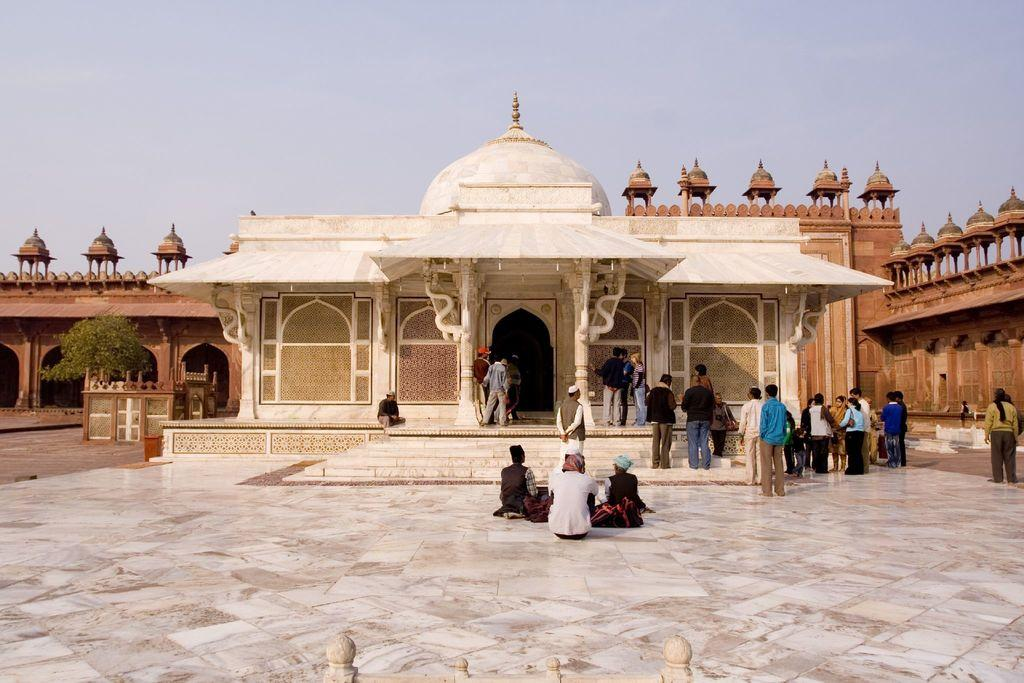What type of architecture is depicted in the image? There is a building with pillars and arches in the image. What is happening in front of the building? There are many people in front of the building. What can be seen on the left side of the image? There is a tree on the left side of the image. What is visible in the background of the image? The sky is visible in the background of the image. What hobbies do the people in the image have? There is no information about the hobbies of the people in the image. --- Facts: 1. There is a car in the image. 2. The car is red. 3. The car has four wheels. 4. There is a road in the image. 5. The road is paved. Absurd Topics: parrot, ocean, dance Conversation: What is the main subject of the image? The main subject of the image is a car. What color is the car? The car is red. How many wheels does the car have? The car has four wheels. What is the surface of the road in the image? The road is paved. Reasoning: Let's think step by step in order to produce the conversation. We start by identifying the main subject of the image, which is the car. Then, we describe specific details about the car, such as its color and the number of wheels. Finally, we mention the road in the image and its surface. Each question is designed to elicit a specific detail about the image that is known from the provided facts. Absurd Question/Answer: Can you see a parrot flying over the ocean in the image? There is no parrot or ocean present in the image. 